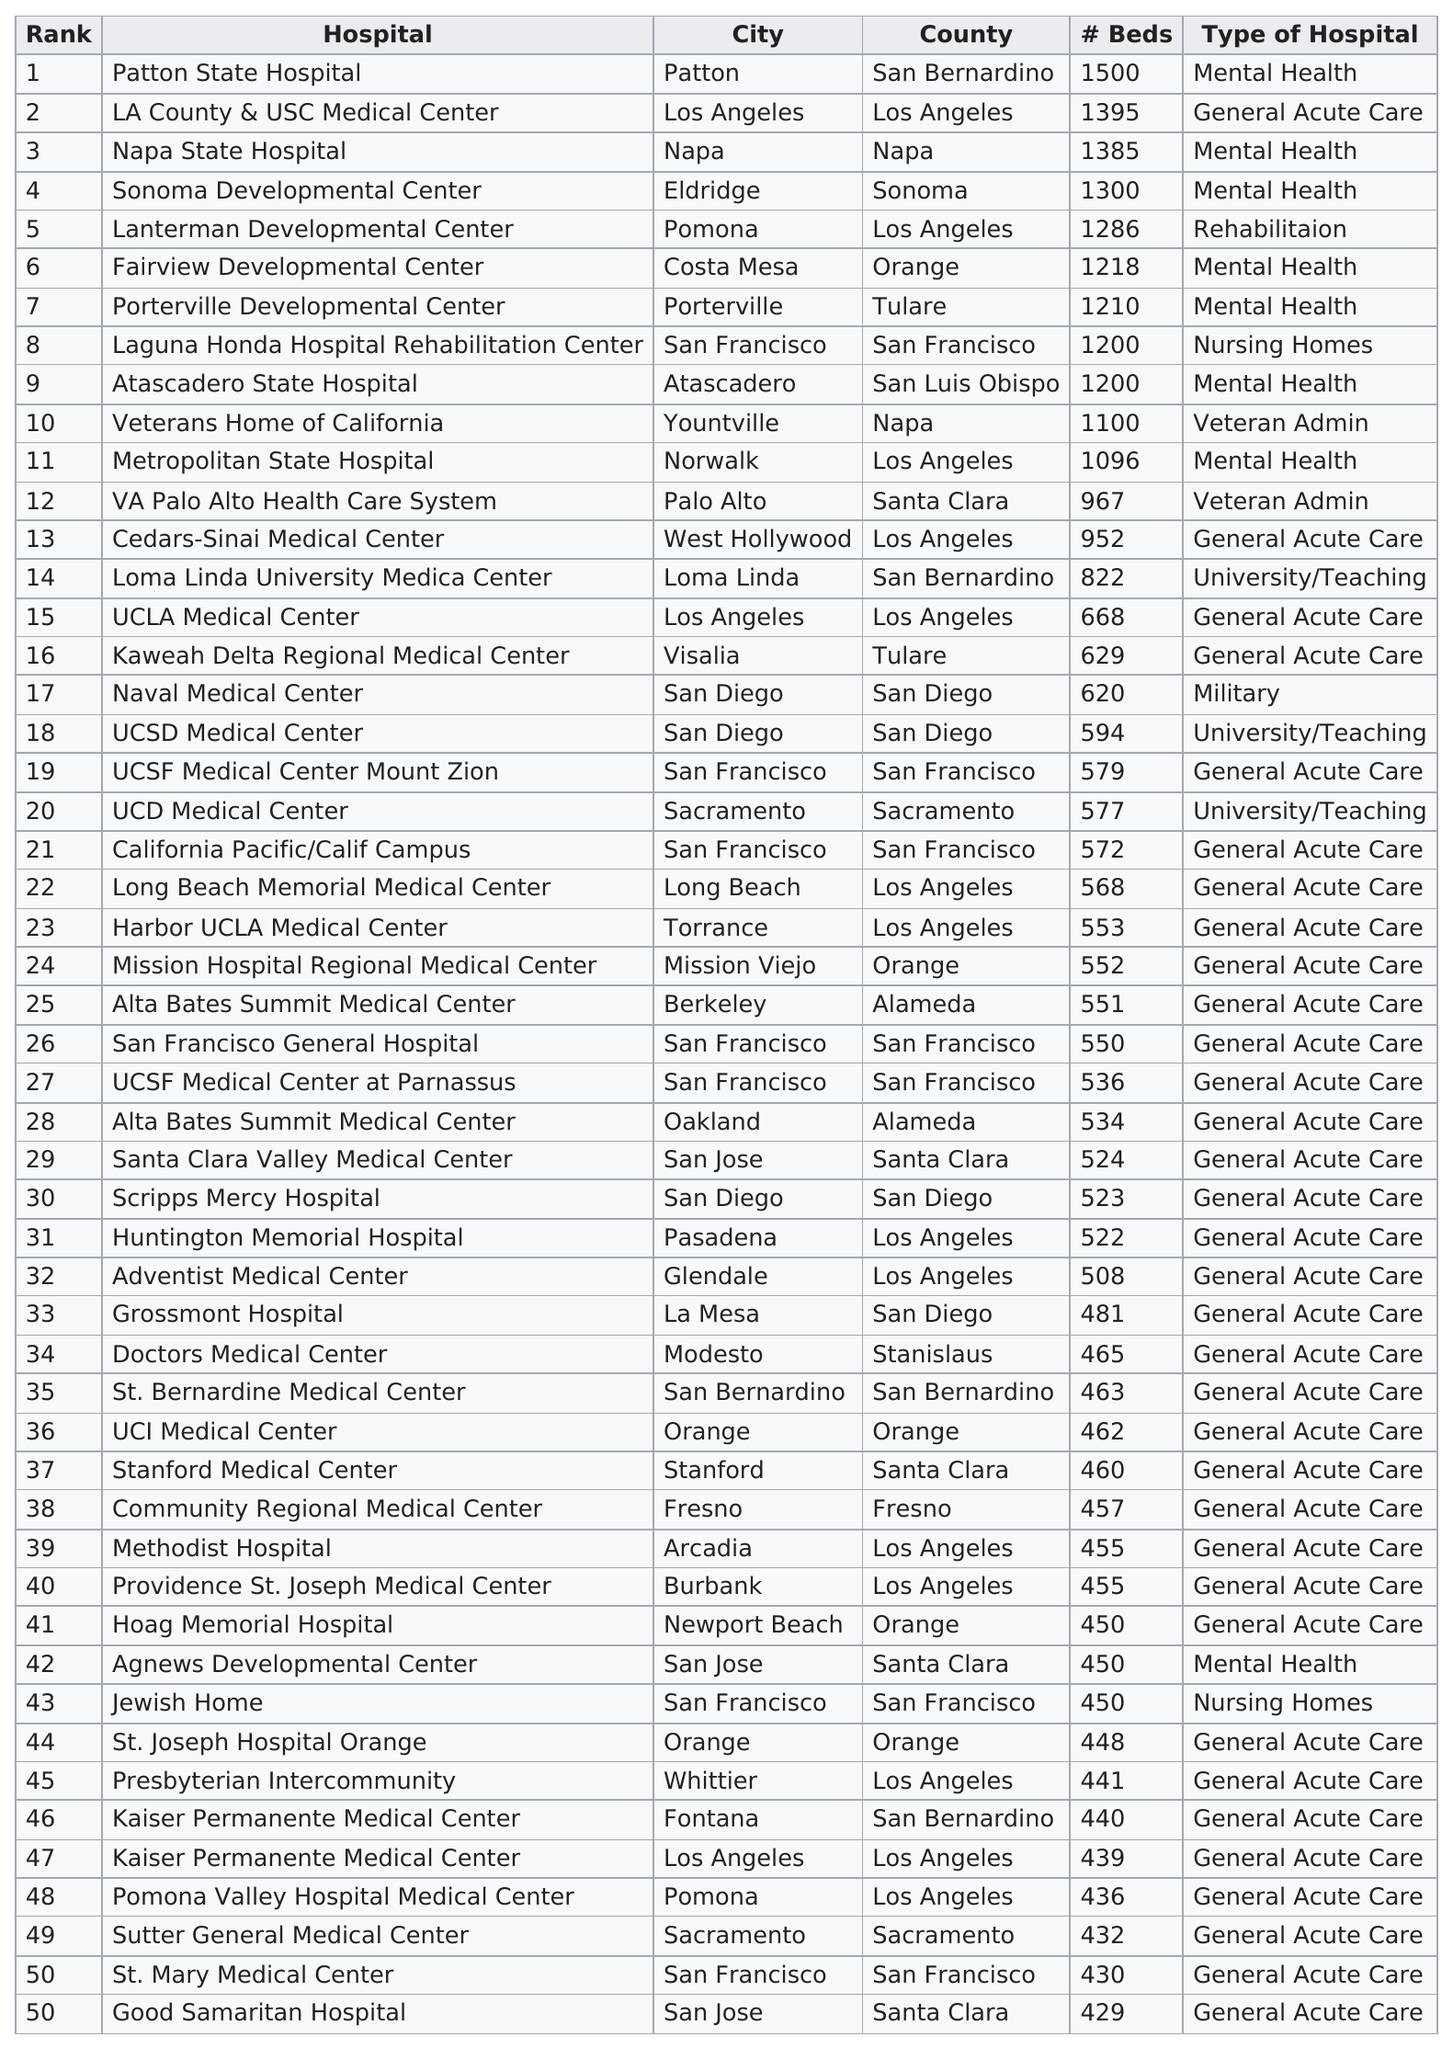Point out several critical features in this image. Laguna Honda Hospital Rehabilitation Center and Atascadero State Hospital, both holding consecutive rankings of 8 and 9 respectively, provide a combined total of 1200 hospital beds. There are currently 33 general acute care hospitals in California, and there are significantly fewer rehabilitation hospitals in the state. Lanterman Developmental Center in Los Angeles County is a hospital that provides hospital beds specifically for rehabilitation and is ranked among the top 10 hospitals in the county. The fact that Patton State Hospital in the city of Patton in San Bernardino County has more mental health hospital beds than Atascadero State Hospital in Atascadero, San Luis Obispo County is indeed a declaration. There are 11 hospitals that have at least 1,000 beds. 